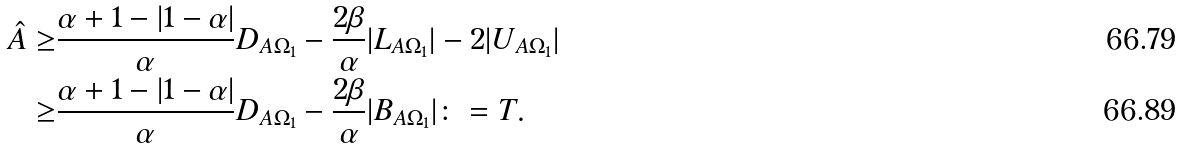<formula> <loc_0><loc_0><loc_500><loc_500>\hat { A } \geq & \frac { \alpha + 1 - | 1 - \alpha | } { \alpha } D _ { A \Omega _ { 1 } } - \frac { 2 \beta } { \alpha } | L _ { A \Omega _ { 1 } } | - 2 | U _ { A \Omega _ { 1 } } | \\ \geq & \frac { \alpha + 1 - | 1 - \alpha | } { \alpha } D _ { A \Omega _ { 1 } } - \frac { 2 \beta } { \alpha } | B _ { A \Omega _ { 1 } } | \colon = T .</formula> 